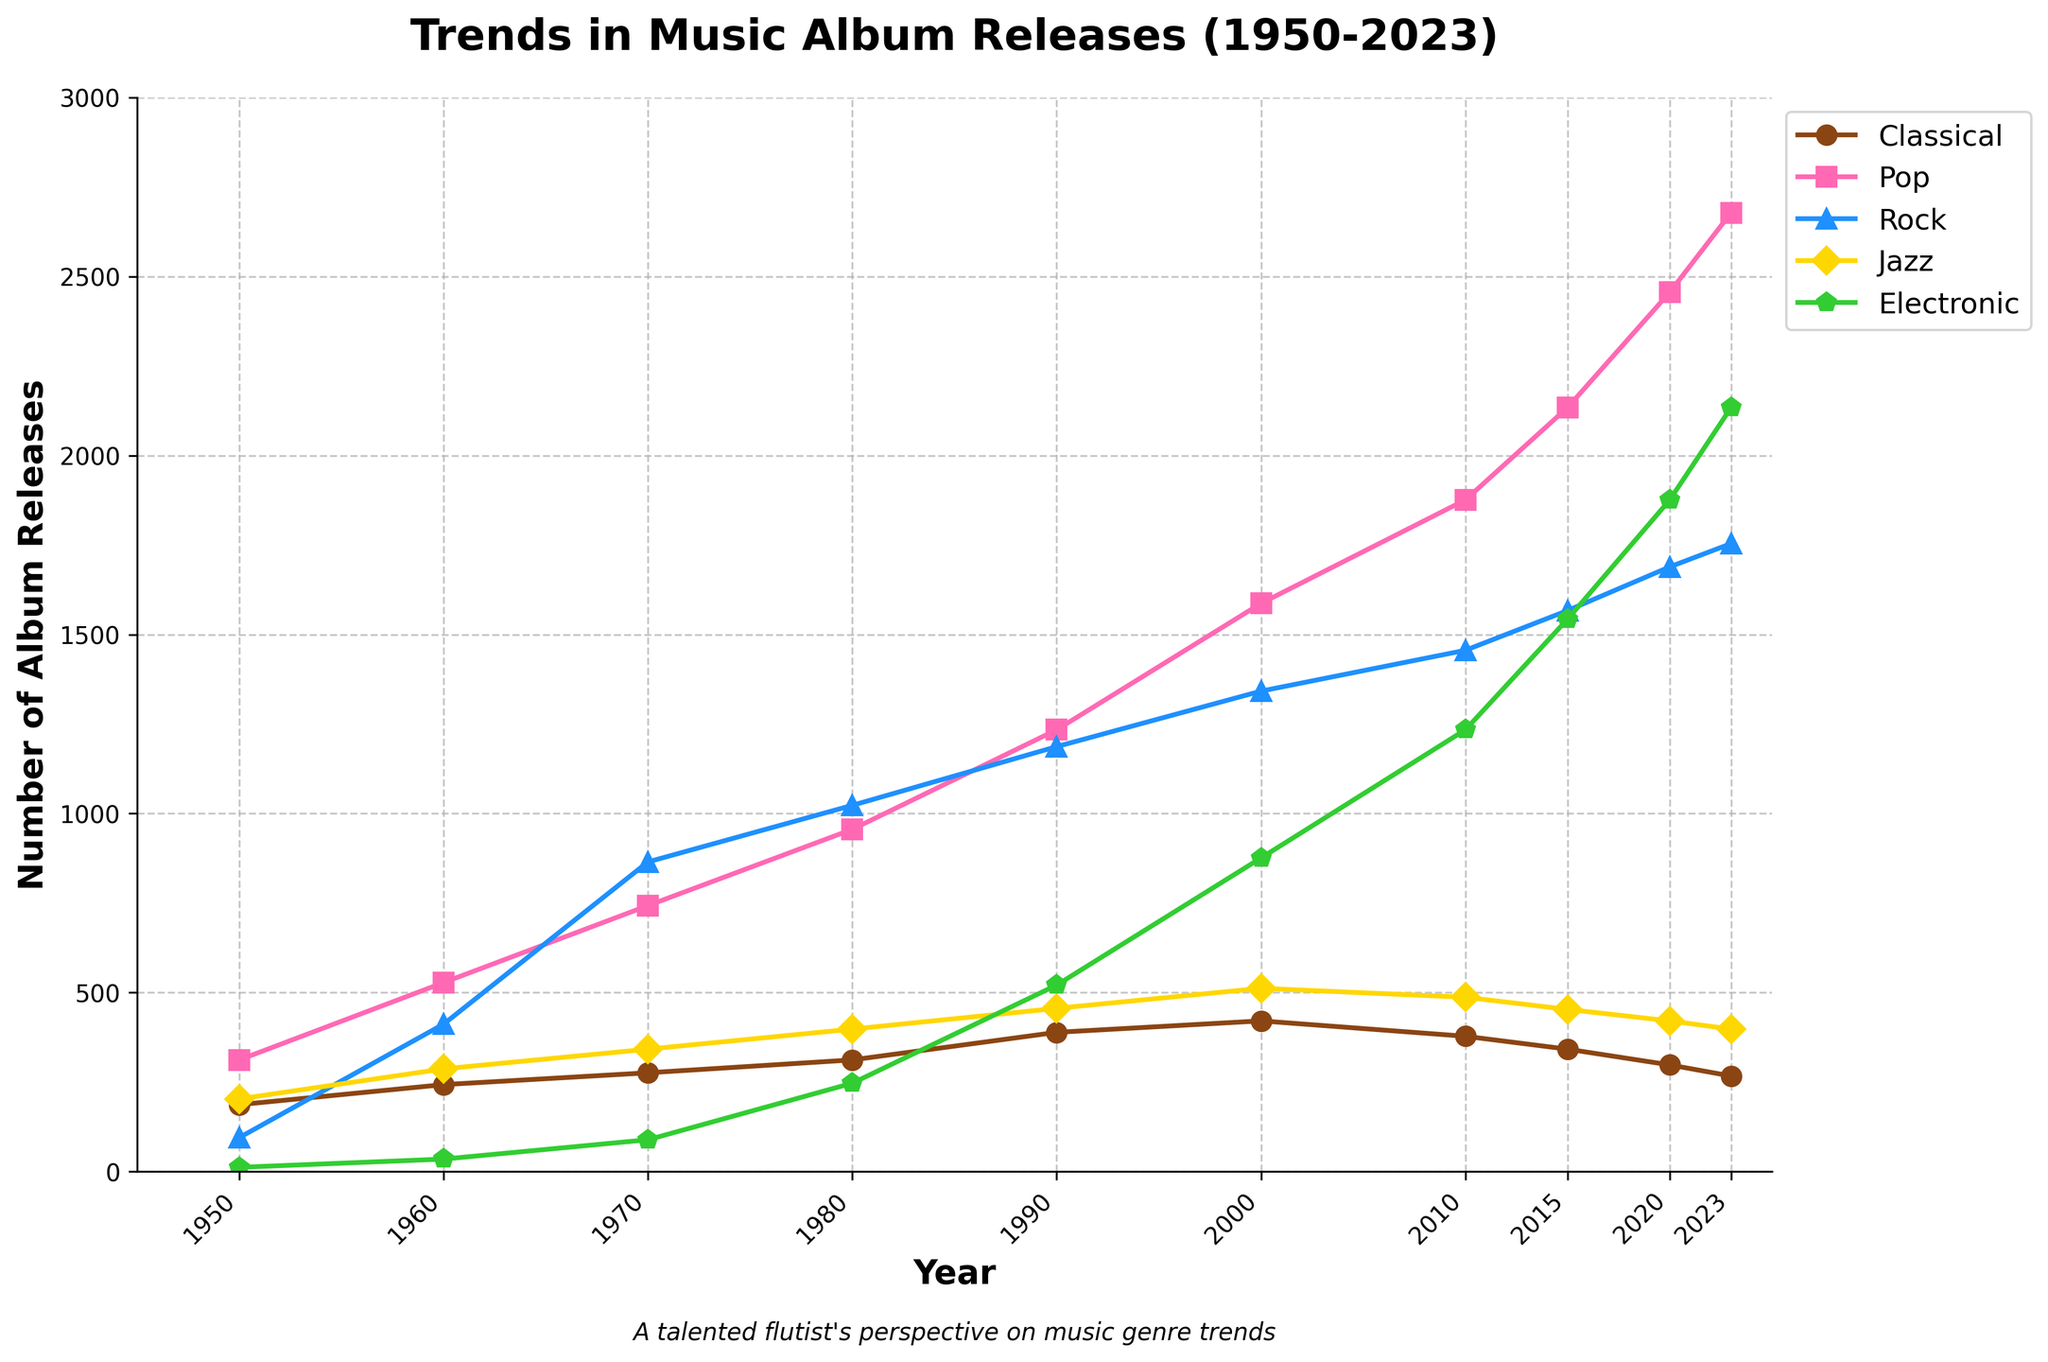What was the overall trend in classical music album releases from 1950 to 2023? Observing the figure, there is a notable increase in classical music album releases from 1950 to 2000, followed by a decline from 2000 to 2023. The highest point is in 2000 with 421 releases, and it decreases thereafter to 267 in 2023.
Answer: Declining after 2000 How did the number of album releases in the pop genre in 2023 compare to the classical genre in the same year? In the figure, the pop genre has 2678 album releases in 2023 whereas the classical genre has 267. Comparing the two, pop has significantly more releases than classical.
Answer: Pop is higher Between which years did rock albums show the most significant increase in releases? Between 1950 and 1960, rock albums increased from 95 to 412 releases. However, the most significant rise is between 1960 and 1970, where it rose from 412 to 865 releases.
Answer: 1960 to 1970 Considering data for jazz and electronic genres, what is the difference in album releases in 2020? According to the figure, in 2020, the number of jazz album releases was 421, while electronic album releases were 1876. The difference is calculated as 1876 - 421.
Answer: 1455 What visual trend can be observed for album releases in the electronic genre from 1950 to 2023? From the figure, the electronic genre started low in 1950 with 12 releases and experienced a constant increase over the years, reaching a peak in 2023 with 2134 releases.
Answer: Increasing trend Which genre had the most releases in 1980 and what color represents it? The figure indicates that in 1980, the pop genre had the most releases with 956 albums. This genre is represented by the color pink.
Answer: Pop, pink color If you sum the number of releases for all genres in 1960, what is the total? Adding values from the figure for 1960: Classical (243) + Pop (528) + Rock (412) + Jazz (287) + Electronic (35). The total is 243 + 528 + 412 + 287 + 35.
Answer: 1505 Which genre exhibited the sharpest decline in album releases between 2000 and 2023? Observing the figure, classical music declined from 421 releases in 2000 to 267 in 2023, which is a noticeable drop, suggesting the sharpest decline.
Answer: Classical What is the difference in the number of rock album releases between 1950 and 1990? From the figure, in 1950 there were 95 rock releases, and in 1990 there were 1187 rock releases. The difference is calculated as 1187 - 95.
Answer: 1092 Which two genres had similar album release numbers in 2010 and what were those numbers? From the figure, in 2010, the jazz genre had 487 releases, and the classic genre had 378 releases. Though they are not identical, they are relatively close in numbers compared to other genres.
Answer: Jazz (487), Classic (378) 